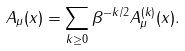<formula> <loc_0><loc_0><loc_500><loc_500>A _ { \mu } ( x ) = \sum _ { k \geq 0 } \beta ^ { - k / 2 } A _ { \mu } ^ { ( k ) } ( x ) .</formula> 